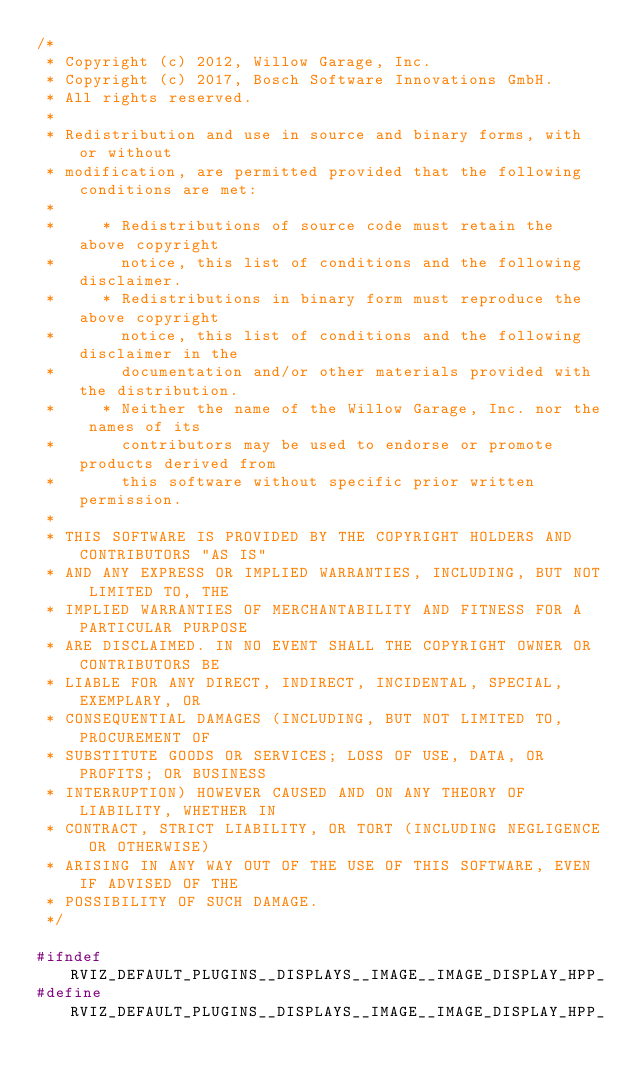<code> <loc_0><loc_0><loc_500><loc_500><_C++_>/*
 * Copyright (c) 2012, Willow Garage, Inc.
 * Copyright (c) 2017, Bosch Software Innovations GmbH.
 * All rights reserved.
 *
 * Redistribution and use in source and binary forms, with or without
 * modification, are permitted provided that the following conditions are met:
 *
 *     * Redistributions of source code must retain the above copyright
 *       notice, this list of conditions and the following disclaimer.
 *     * Redistributions in binary form must reproduce the above copyright
 *       notice, this list of conditions and the following disclaimer in the
 *       documentation and/or other materials provided with the distribution.
 *     * Neither the name of the Willow Garage, Inc. nor the names of its
 *       contributors may be used to endorse or promote products derived from
 *       this software without specific prior written permission.
 *
 * THIS SOFTWARE IS PROVIDED BY THE COPYRIGHT HOLDERS AND CONTRIBUTORS "AS IS"
 * AND ANY EXPRESS OR IMPLIED WARRANTIES, INCLUDING, BUT NOT LIMITED TO, THE
 * IMPLIED WARRANTIES OF MERCHANTABILITY AND FITNESS FOR A PARTICULAR PURPOSE
 * ARE DISCLAIMED. IN NO EVENT SHALL THE COPYRIGHT OWNER OR CONTRIBUTORS BE
 * LIABLE FOR ANY DIRECT, INDIRECT, INCIDENTAL, SPECIAL, EXEMPLARY, OR
 * CONSEQUENTIAL DAMAGES (INCLUDING, BUT NOT LIMITED TO, PROCUREMENT OF
 * SUBSTITUTE GOODS OR SERVICES; LOSS OF USE, DATA, OR PROFITS; OR BUSINESS
 * INTERRUPTION) HOWEVER CAUSED AND ON ANY THEORY OF LIABILITY, WHETHER IN
 * CONTRACT, STRICT LIABILITY, OR TORT (INCLUDING NEGLIGENCE OR OTHERWISE)
 * ARISING IN ANY WAY OUT OF THE USE OF THIS SOFTWARE, EVEN IF ADVISED OF THE
 * POSSIBILITY OF SUCH DAMAGE.
 */

#ifndef RVIZ_DEFAULT_PLUGINS__DISPLAYS__IMAGE__IMAGE_DISPLAY_HPP_
#define RVIZ_DEFAULT_PLUGINS__DISPLAYS__IMAGE__IMAGE_DISPLAY_HPP_
</code> 